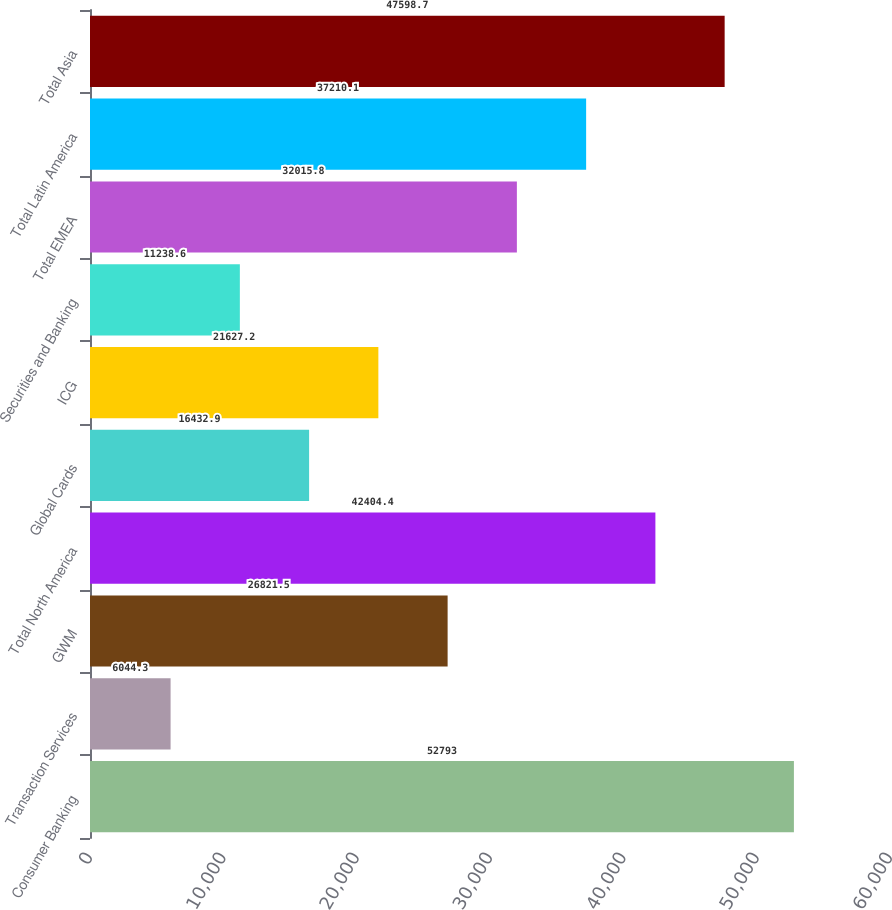<chart> <loc_0><loc_0><loc_500><loc_500><bar_chart><fcel>Consumer Banking<fcel>Transaction Services<fcel>GWM<fcel>Total North America<fcel>Global Cards<fcel>ICG<fcel>Securities and Banking<fcel>Total EMEA<fcel>Total Latin America<fcel>Total Asia<nl><fcel>52793<fcel>6044.3<fcel>26821.5<fcel>42404.4<fcel>16432.9<fcel>21627.2<fcel>11238.6<fcel>32015.8<fcel>37210.1<fcel>47598.7<nl></chart> 